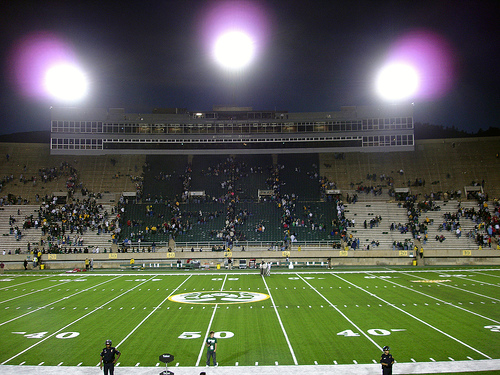<image>
Is there a stands next to the field? Yes. The stands is positioned adjacent to the field, located nearby in the same general area. Where is the light in relation to the player? Is it above the player? No. The light is not positioned above the player. The vertical arrangement shows a different relationship. 